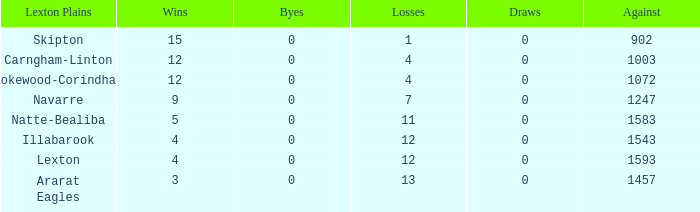What team has fewer than 9 wins and less than 1593 against? Natte-Bealiba, Illabarook, Ararat Eagles. 